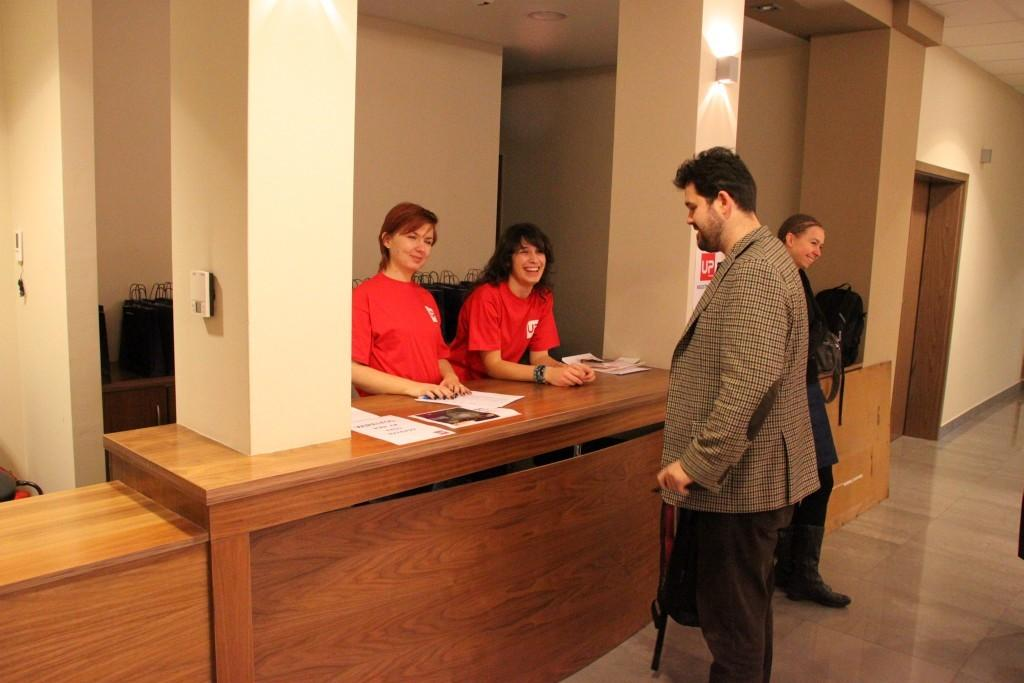How many people are present in the image? There are four people in the image. Can you describe the gender of the people? Two of the people are girls. What are the girls wearing that is similar? The girls are wearing t-shirts of the same color. How are the other two people positioned in relation to the girls? The other two people are opposite the girls. What type of structure can be seen exploding in the background of the image? There is no structure or explosion present in the image. Can you describe the window through which the bomb is being thrown? There is no window or bomb present in the image. 